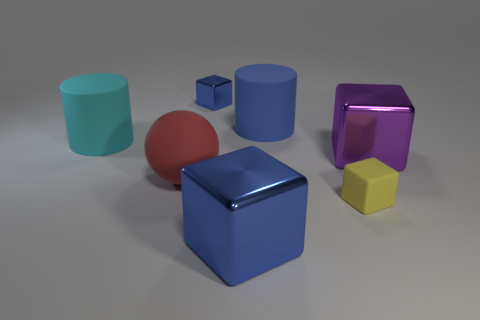Is the color of the large cube that is left of the yellow matte thing the same as the small metal object? Yes, the color of the large blue cube located to the left of the yellow matte object—a hexagonal prism—matches the color of the small blue cube as well. They both share a similar hue of blue, although the difference in material textures might slightly affect the perception of color. 